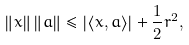Convert formula to latex. <formula><loc_0><loc_0><loc_500><loc_500>\left \| x \right \| \left \| a \right \| \leq \left | \left \langle x , a \right \rangle \right | + \frac { 1 } { 2 } r ^ { 2 } ,</formula> 